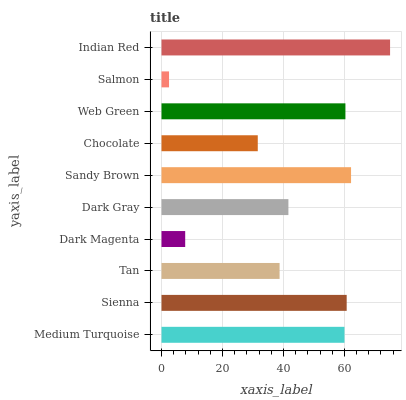Is Salmon the minimum?
Answer yes or no. Yes. Is Indian Red the maximum?
Answer yes or no. Yes. Is Sienna the minimum?
Answer yes or no. No. Is Sienna the maximum?
Answer yes or no. No. Is Sienna greater than Medium Turquoise?
Answer yes or no. Yes. Is Medium Turquoise less than Sienna?
Answer yes or no. Yes. Is Medium Turquoise greater than Sienna?
Answer yes or no. No. Is Sienna less than Medium Turquoise?
Answer yes or no. No. Is Medium Turquoise the high median?
Answer yes or no. Yes. Is Dark Gray the low median?
Answer yes or no. Yes. Is Salmon the high median?
Answer yes or no. No. Is Indian Red the low median?
Answer yes or no. No. 